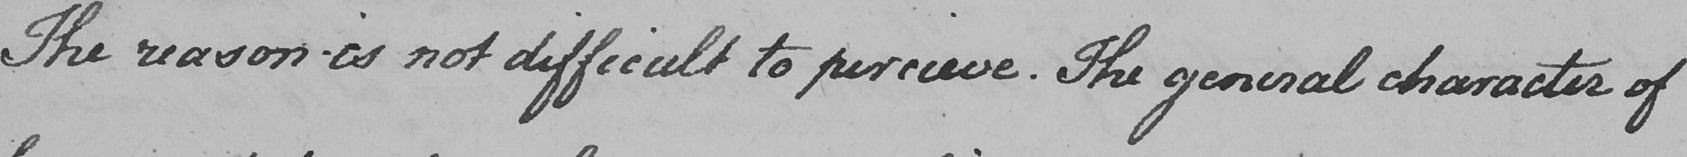Please provide the text content of this handwritten line. The reason is not difficult to percieve . The general character of 